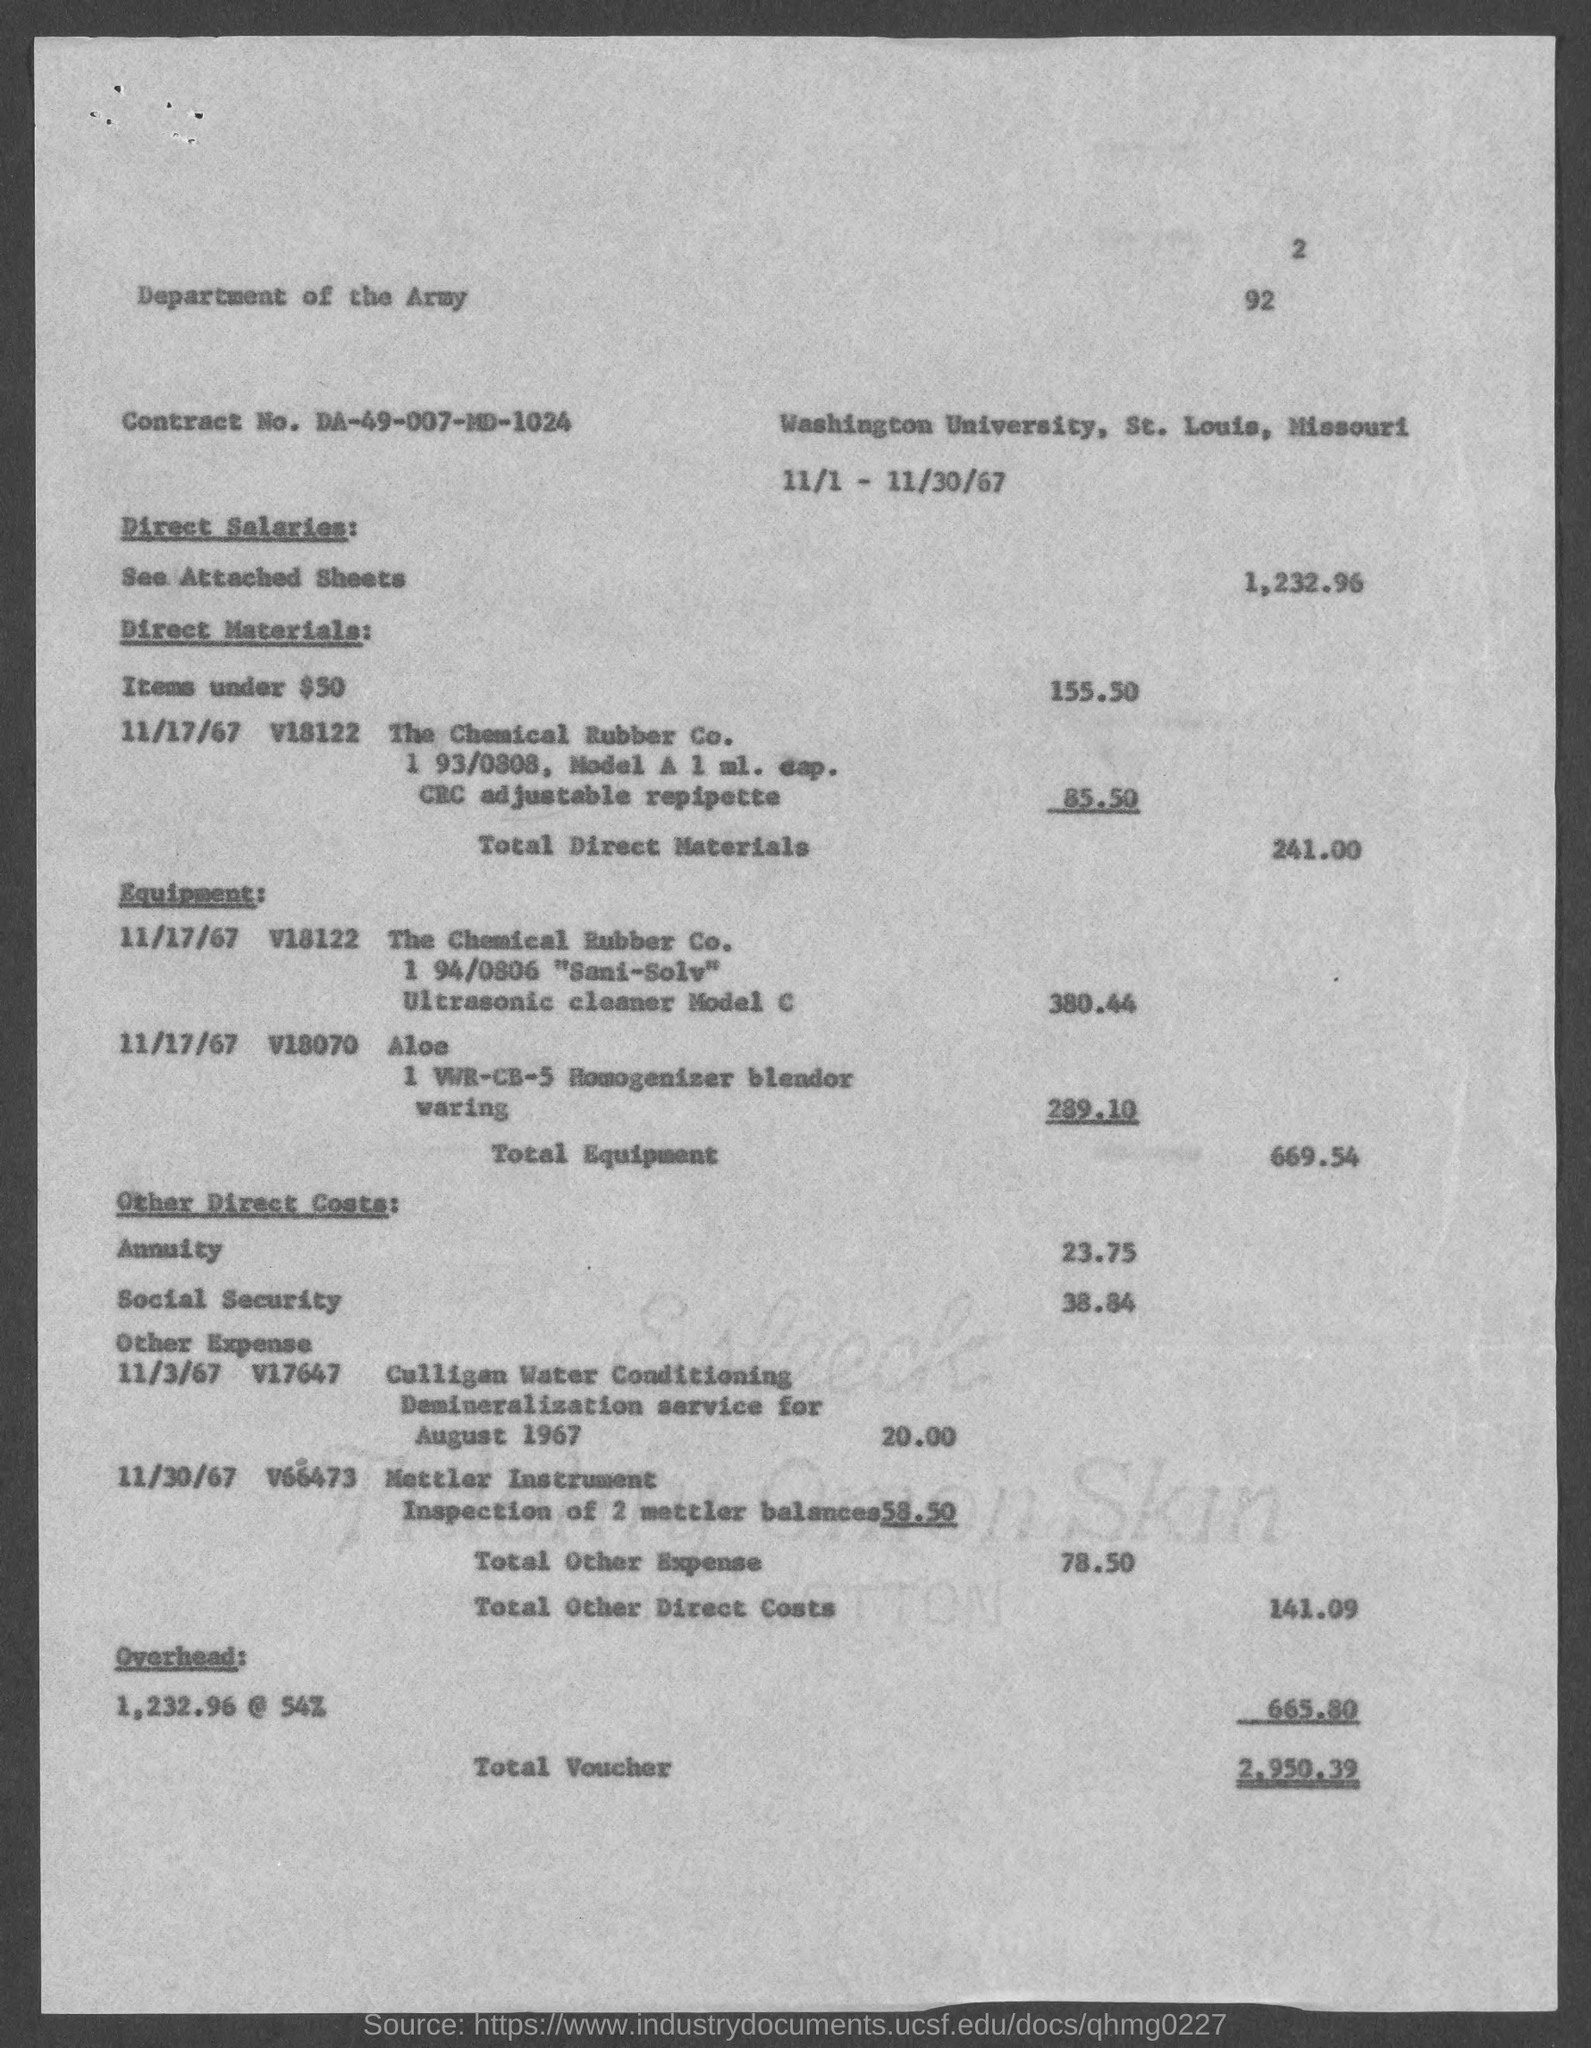Specify some key components in this picture. The direct salaries cost mentioned in the document is 1,232.96. The overhead cost mentioned in the document is approximately 665.80... The Contract No. given in the document is DA-49-007-MD-1024. The total direct materials cost, as mentioned in the document, is 241.00. The total voucher amount stated in the document is 2,950.39. 